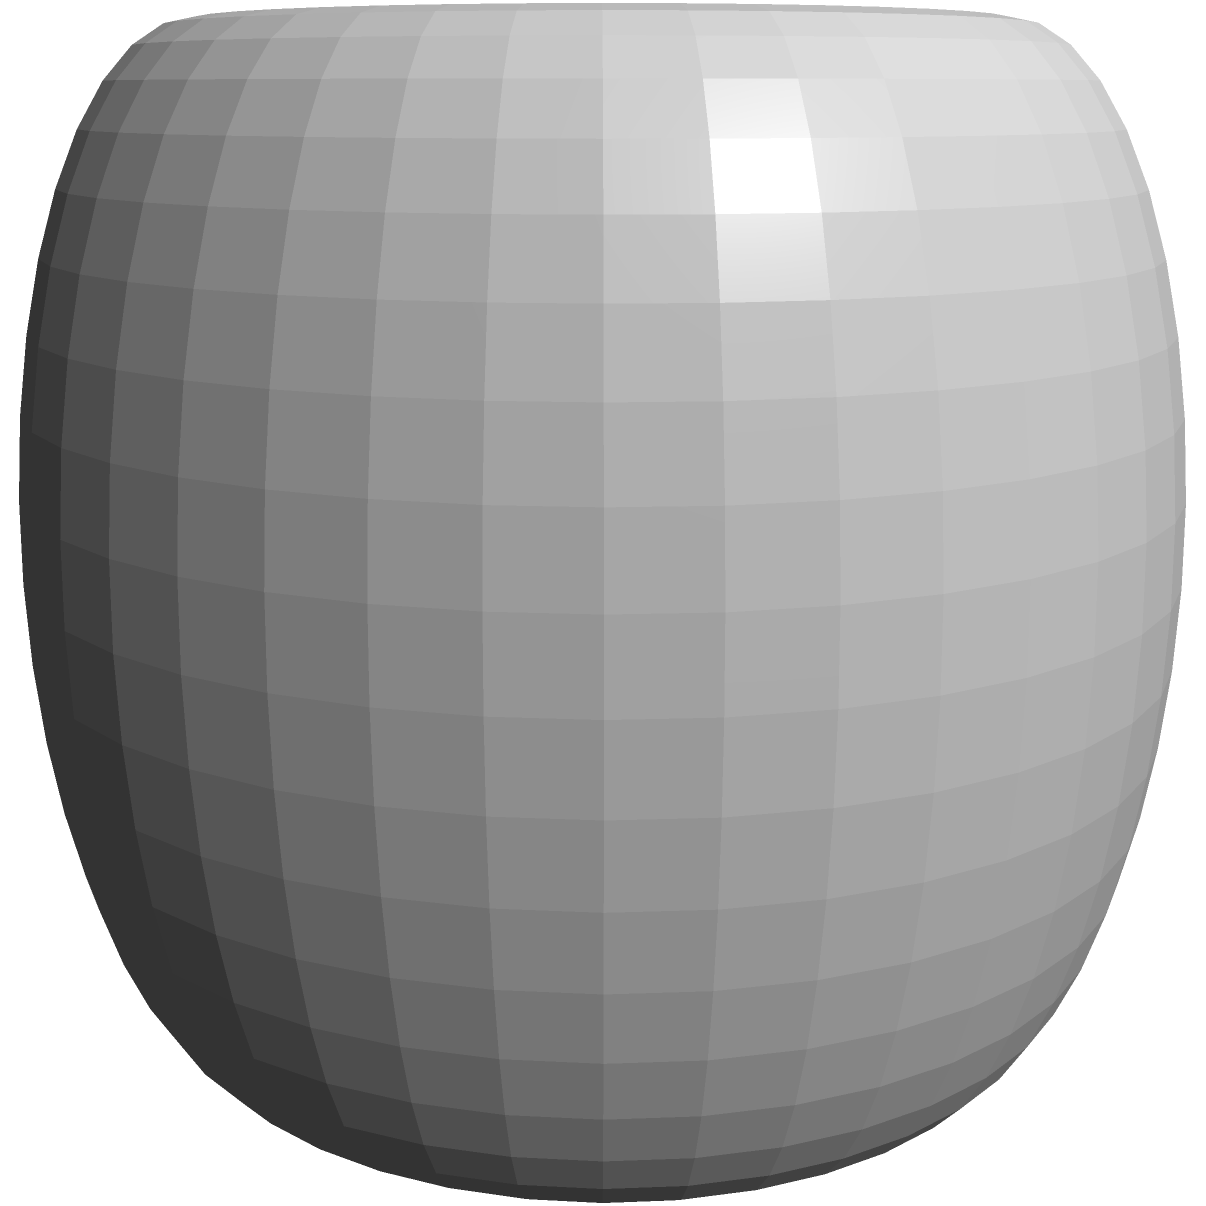In a futuristic sci-fi film, an alien planet is modeled as a torus with additional sinusoidal variations. The planet's shape is described by the parametric equations:

$$x = (R + a \cos v) \cos u$$
$$y = (R + a \cos v) \sin u$$
$$z = b \sin v$$

Where $R = 2$, $a = 1$, and $b = 0.5$ (all in arbitrary units). Calculate the surface area of this alien planet. To find the surface area of this alien planet, we need to use the surface area formula for parametric surfaces:

1. The surface area is given by the double integral:

   $$A = \iint_S \sqrt{EG - F^2} \, du \, dv$$

   where $E$, $F$, and $G$ are coefficients of the first fundamental form.

2. Calculate partial derivatives:
   $$\frac{\partial x}{\partial u} = -(R + a \cos v) \sin u$$
   $$\frac{\partial y}{\partial u} = (R + a \cos v) \cos u$$
   $$\frac{\partial z}{\partial u} = 0$$
   $$\frac{\partial x}{\partial v} = -a \sin v \cos u$$
   $$\frac{\partial y}{\partial v} = -a \sin v \sin u$$
   $$\frac{\partial z}{\partial v} = b \cos v$$

3. Calculate $E$, $F$, and $G$:
   $$E = (\frac{\partial x}{\partial u})^2 + (\frac{\partial y}{\partial u})^2 + (\frac{\partial z}{\partial u})^2 = (R + a \cos v)^2$$
   $$F = \frac{\partial x}{\partial u}\frac{\partial x}{\partial v} + \frac{\partial y}{\partial u}\frac{\partial y}{\partial v} + \frac{\partial z}{\partial u}\frac{\partial z}{\partial v} = 0$$
   $$G = (\frac{\partial x}{\partial v})^2 + (\frac{\partial y}{\partial v})^2 + (\frac{\partial z}{\partial v})^2 = a^2 \sin^2 v + b^2 \cos^2 v$$

4. Simplify the integrand:
   $$\sqrt{EG - F^2} = \sqrt{(R + a \cos v)^2(a^2 \sin^2 v + b^2 \cos^2 v)}$$

5. Set up the double integral:
   $$A = \int_0^{2\pi} \int_0^{2\pi} \sqrt{(R + a \cos v)^2(a^2 \sin^2 v + b^2 \cos^2 v)} \, du \, dv$$

6. Simplify and evaluate:
   $$A = 2\pi \int_0^{2\pi} \sqrt{(R + a \cos v)^2(a^2 \sin^2 v + b^2 \cos^2 v)} \, dv$$

7. Substitute the given values ($R = 2$, $a = 1$, $b = 0.5$) and evaluate the integral numerically.

The resulting surface area is approximately 78.96 square units.
Answer: 78.96 square units 